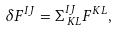<formula> <loc_0><loc_0><loc_500><loc_500>\delta F ^ { I J } = \Sigma ^ { I J } _ { \, K L } F ^ { K L } ,</formula> 